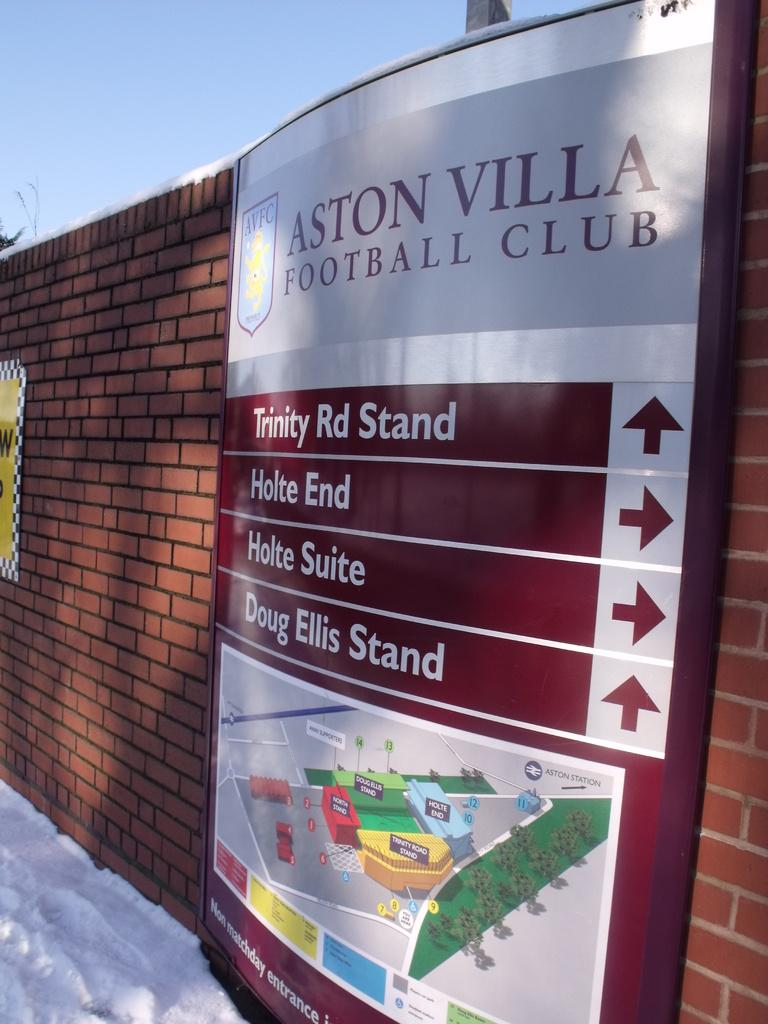<image>
Relay a brief, clear account of the picture shown. a sign at the aston vila football club showing direction to different parts of the club 